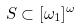Convert formula to latex. <formula><loc_0><loc_0><loc_500><loc_500>S \subset [ \omega _ { 1 } ] ^ { \omega }</formula> 